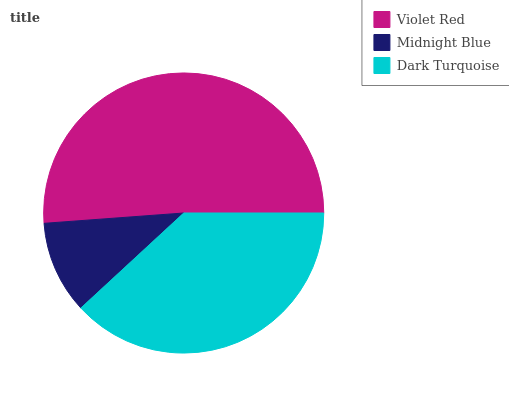Is Midnight Blue the minimum?
Answer yes or no. Yes. Is Violet Red the maximum?
Answer yes or no. Yes. Is Dark Turquoise the minimum?
Answer yes or no. No. Is Dark Turquoise the maximum?
Answer yes or no. No. Is Dark Turquoise greater than Midnight Blue?
Answer yes or no. Yes. Is Midnight Blue less than Dark Turquoise?
Answer yes or no. Yes. Is Midnight Blue greater than Dark Turquoise?
Answer yes or no. No. Is Dark Turquoise less than Midnight Blue?
Answer yes or no. No. Is Dark Turquoise the high median?
Answer yes or no. Yes. Is Dark Turquoise the low median?
Answer yes or no. Yes. Is Violet Red the high median?
Answer yes or no. No. Is Violet Red the low median?
Answer yes or no. No. 